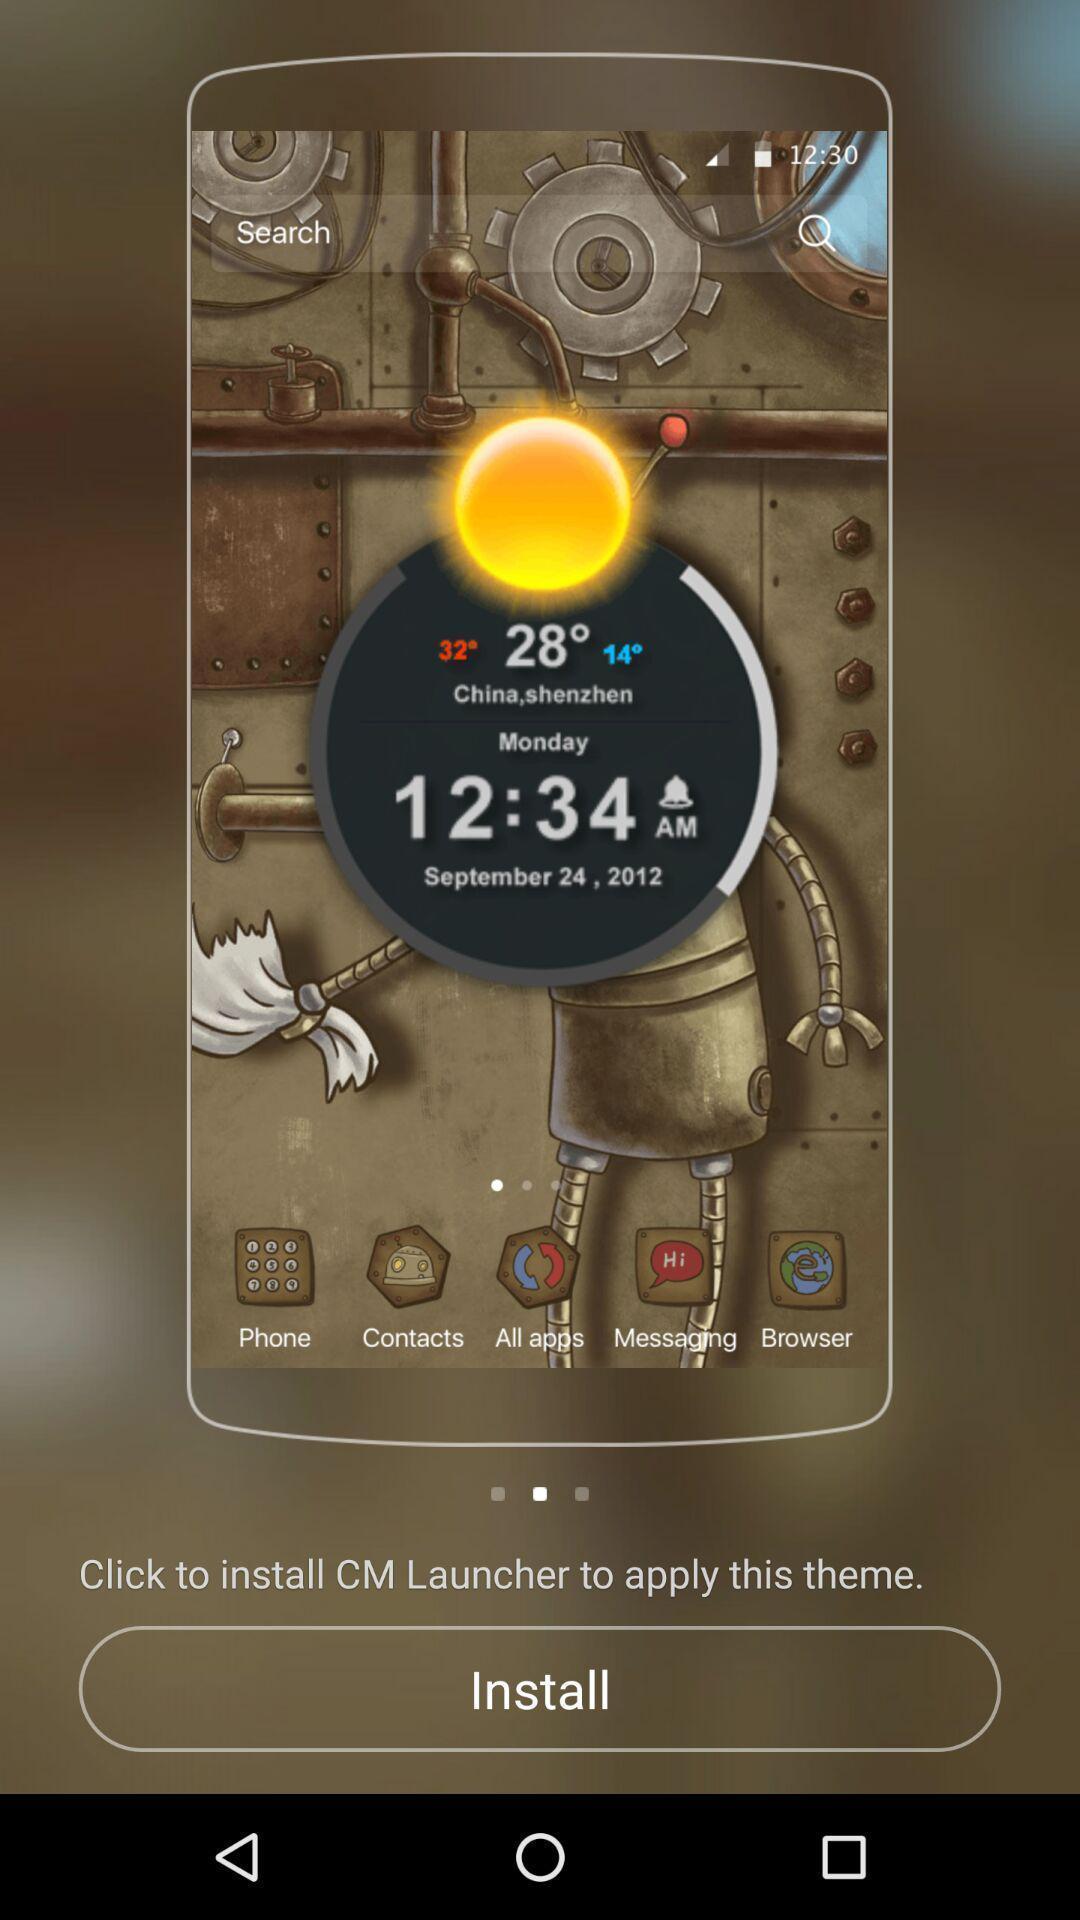Please provide a description for this image. Page showing recommendation to install app. 